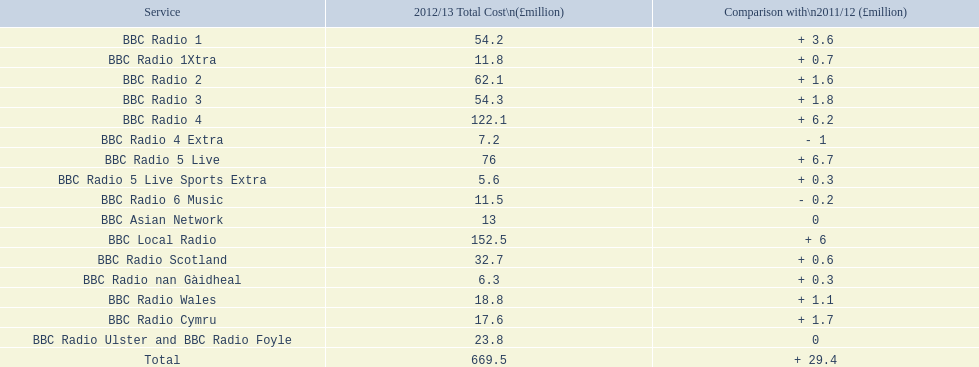What was the largest sum of money spent on running a station in the 2012/13 fiscal year? 152.5. Which station's operating costs amounted to £152.5 million during that time? BBC Local Radio. 